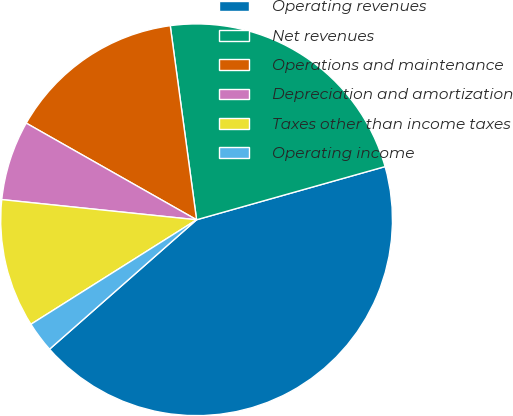Convert chart. <chart><loc_0><loc_0><loc_500><loc_500><pie_chart><fcel>Operating revenues<fcel>Net revenues<fcel>Operations and maintenance<fcel>Depreciation and amortization<fcel>Taxes other than income taxes<fcel>Operating income<nl><fcel>42.89%<fcel>22.77%<fcel>14.64%<fcel>6.57%<fcel>10.6%<fcel>2.53%<nl></chart> 